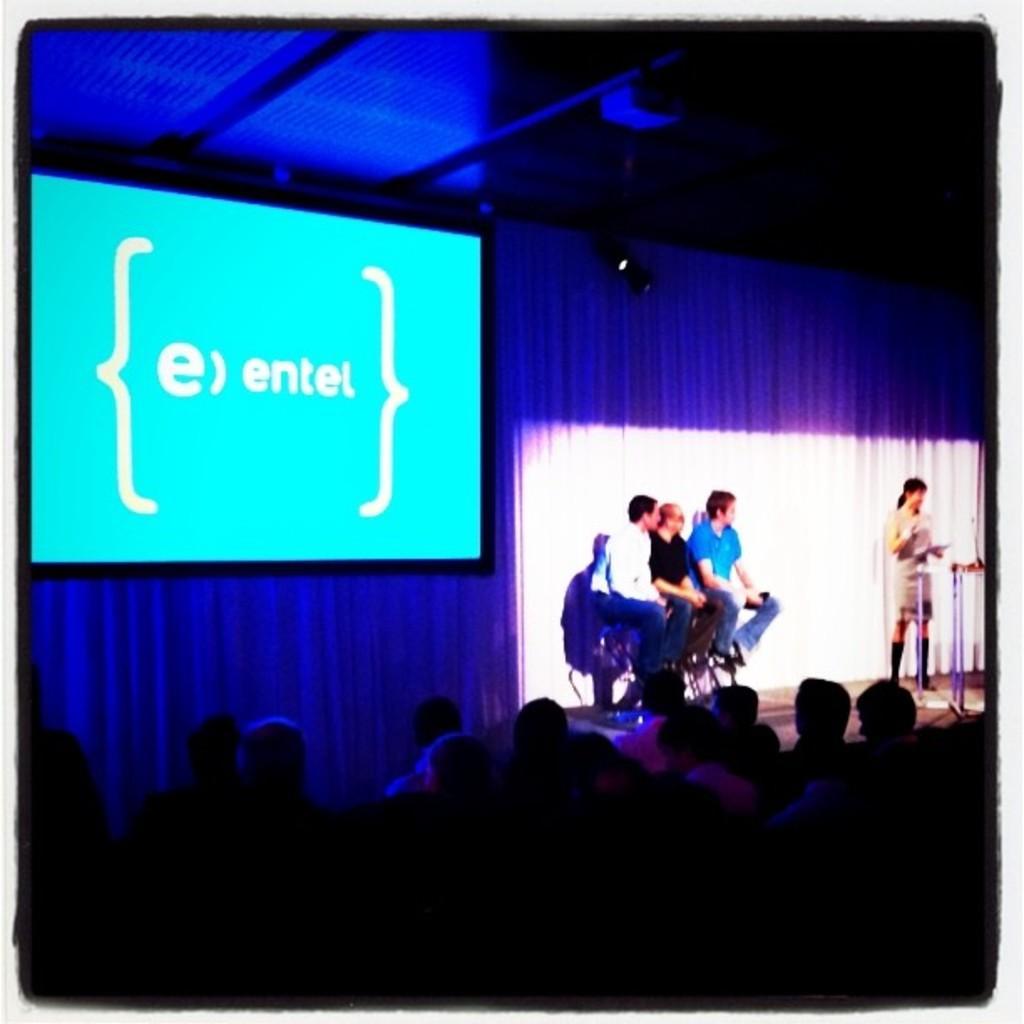Describe this image in one or two sentences. In this image at the bottom there are a group of people who are sitting, and in the center there are some people and there is a curtain. On the left side there is one television, at the top there is ceiling. 